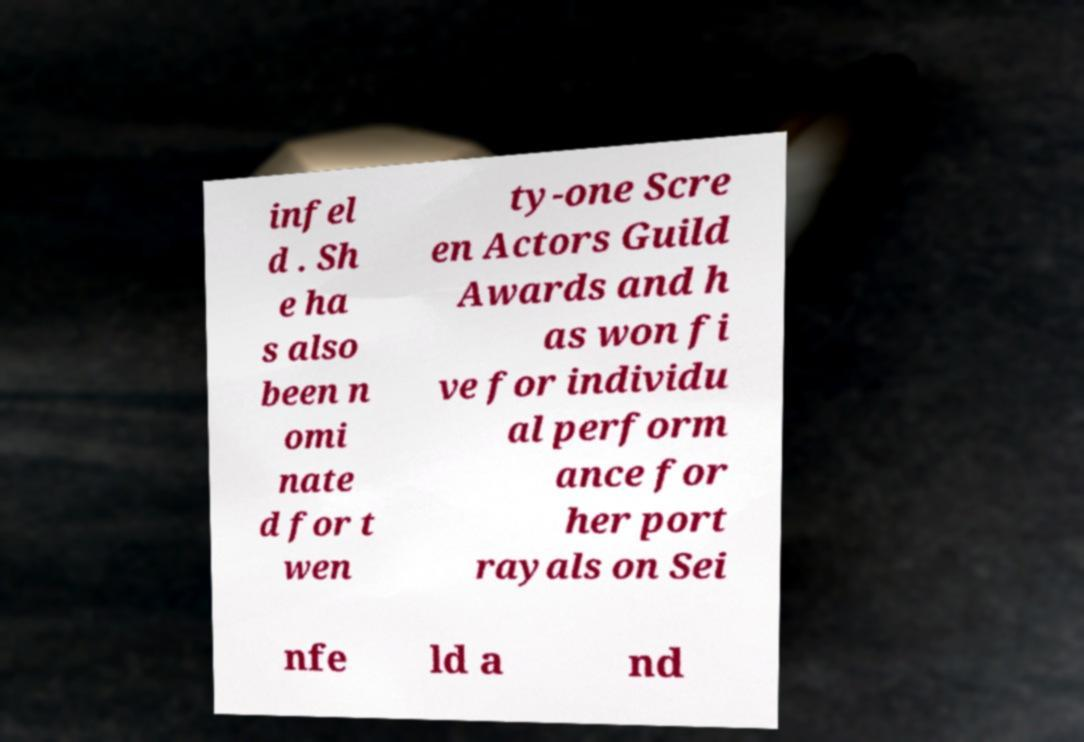I need the written content from this picture converted into text. Can you do that? infel d . Sh e ha s also been n omi nate d for t wen ty-one Scre en Actors Guild Awards and h as won fi ve for individu al perform ance for her port rayals on Sei nfe ld a nd 